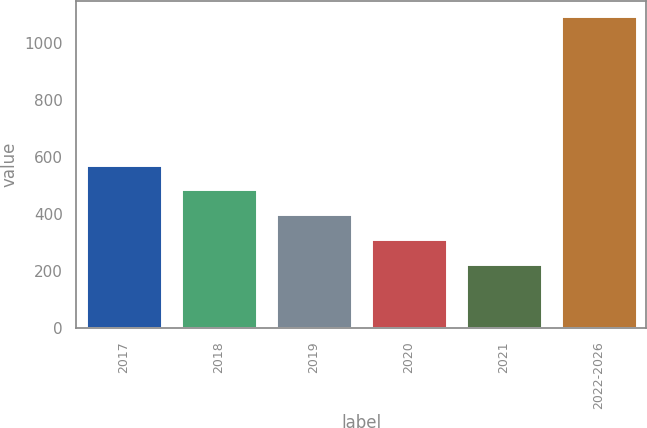Convert chart. <chart><loc_0><loc_0><loc_500><loc_500><bar_chart><fcel>2017<fcel>2018<fcel>2019<fcel>2020<fcel>2021<fcel>2022-2026<nl><fcel>572.2<fcel>485.4<fcel>398.6<fcel>311.8<fcel>225<fcel>1093<nl></chart> 